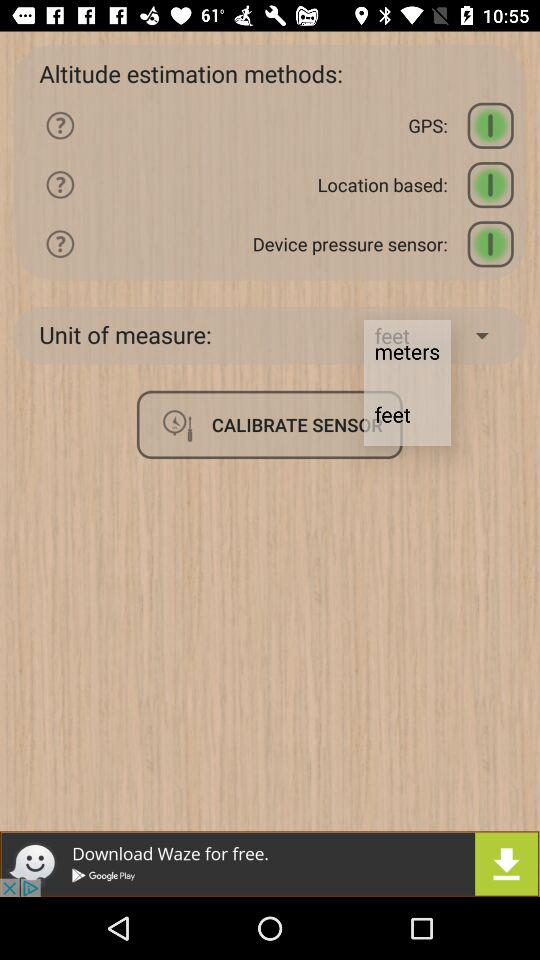How many altitude estimation methods are available?
Answer the question using a single word or phrase. 3 